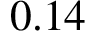Convert formula to latex. <formula><loc_0><loc_0><loc_500><loc_500>0 . 1 4</formula> 